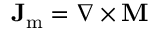<formula> <loc_0><loc_0><loc_500><loc_500>J _ { m } = \nabla \times M</formula> 